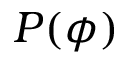Convert formula to latex. <formula><loc_0><loc_0><loc_500><loc_500>P ( \phi )</formula> 